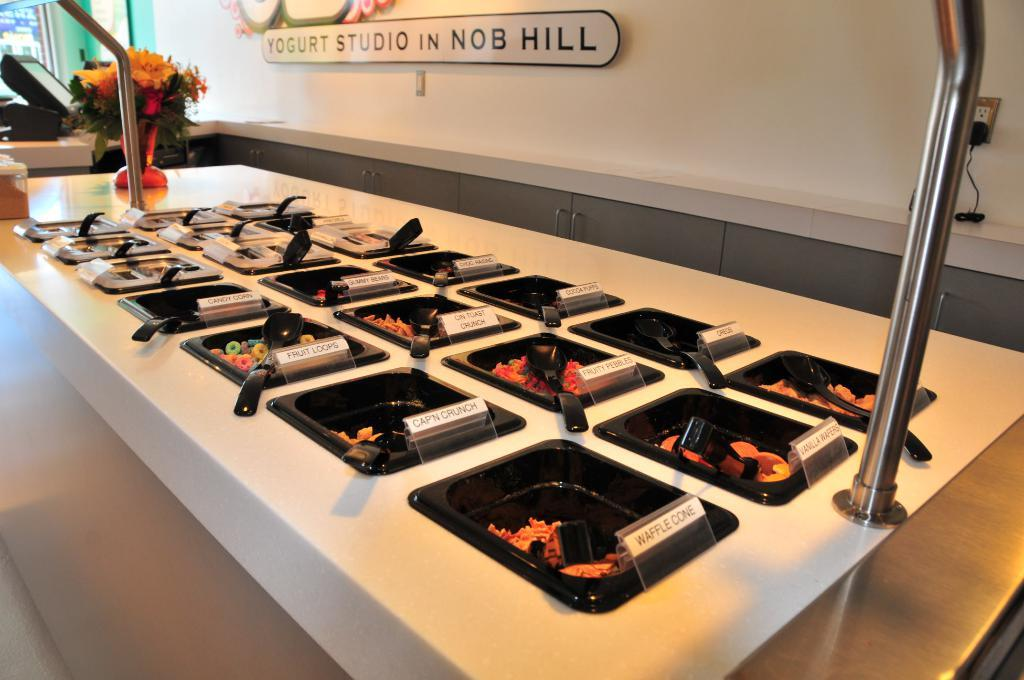<image>
Give a short and clear explanation of the subsequent image. Area that serves food with a sign in the back that says "Yogurt Studio In Nob Hill". 